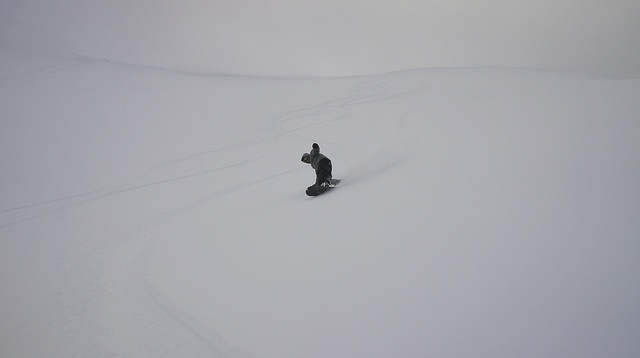Describe the objects in this image and their specific colors. I can see people in gray, black, darkgray, and lightgray tones and snowboard in gray and black tones in this image. 